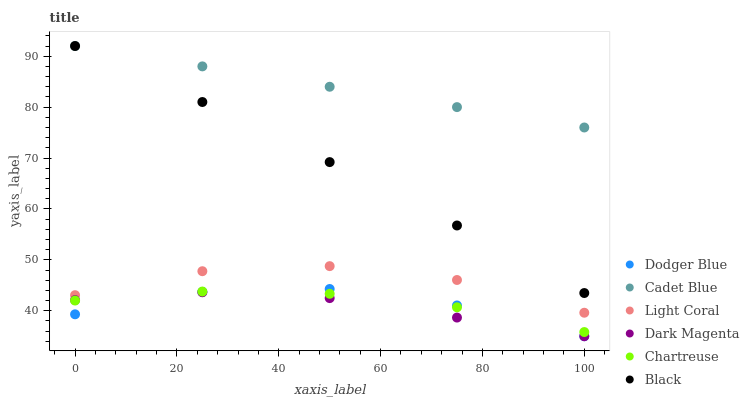Does Dark Magenta have the minimum area under the curve?
Answer yes or no. Yes. Does Cadet Blue have the maximum area under the curve?
Answer yes or no. Yes. Does Light Coral have the minimum area under the curve?
Answer yes or no. No. Does Light Coral have the maximum area under the curve?
Answer yes or no. No. Is Cadet Blue the smoothest?
Answer yes or no. Yes. Is Light Coral the roughest?
Answer yes or no. Yes. Is Dark Magenta the smoothest?
Answer yes or no. No. Is Dark Magenta the roughest?
Answer yes or no. No. Does Dark Magenta have the lowest value?
Answer yes or no. Yes. Does Light Coral have the lowest value?
Answer yes or no. No. Does Black have the highest value?
Answer yes or no. Yes. Does Light Coral have the highest value?
Answer yes or no. No. Is Chartreuse less than Black?
Answer yes or no. Yes. Is Cadet Blue greater than Dodger Blue?
Answer yes or no. Yes. Does Dark Magenta intersect Dodger Blue?
Answer yes or no. Yes. Is Dark Magenta less than Dodger Blue?
Answer yes or no. No. Is Dark Magenta greater than Dodger Blue?
Answer yes or no. No. Does Chartreuse intersect Black?
Answer yes or no. No. 